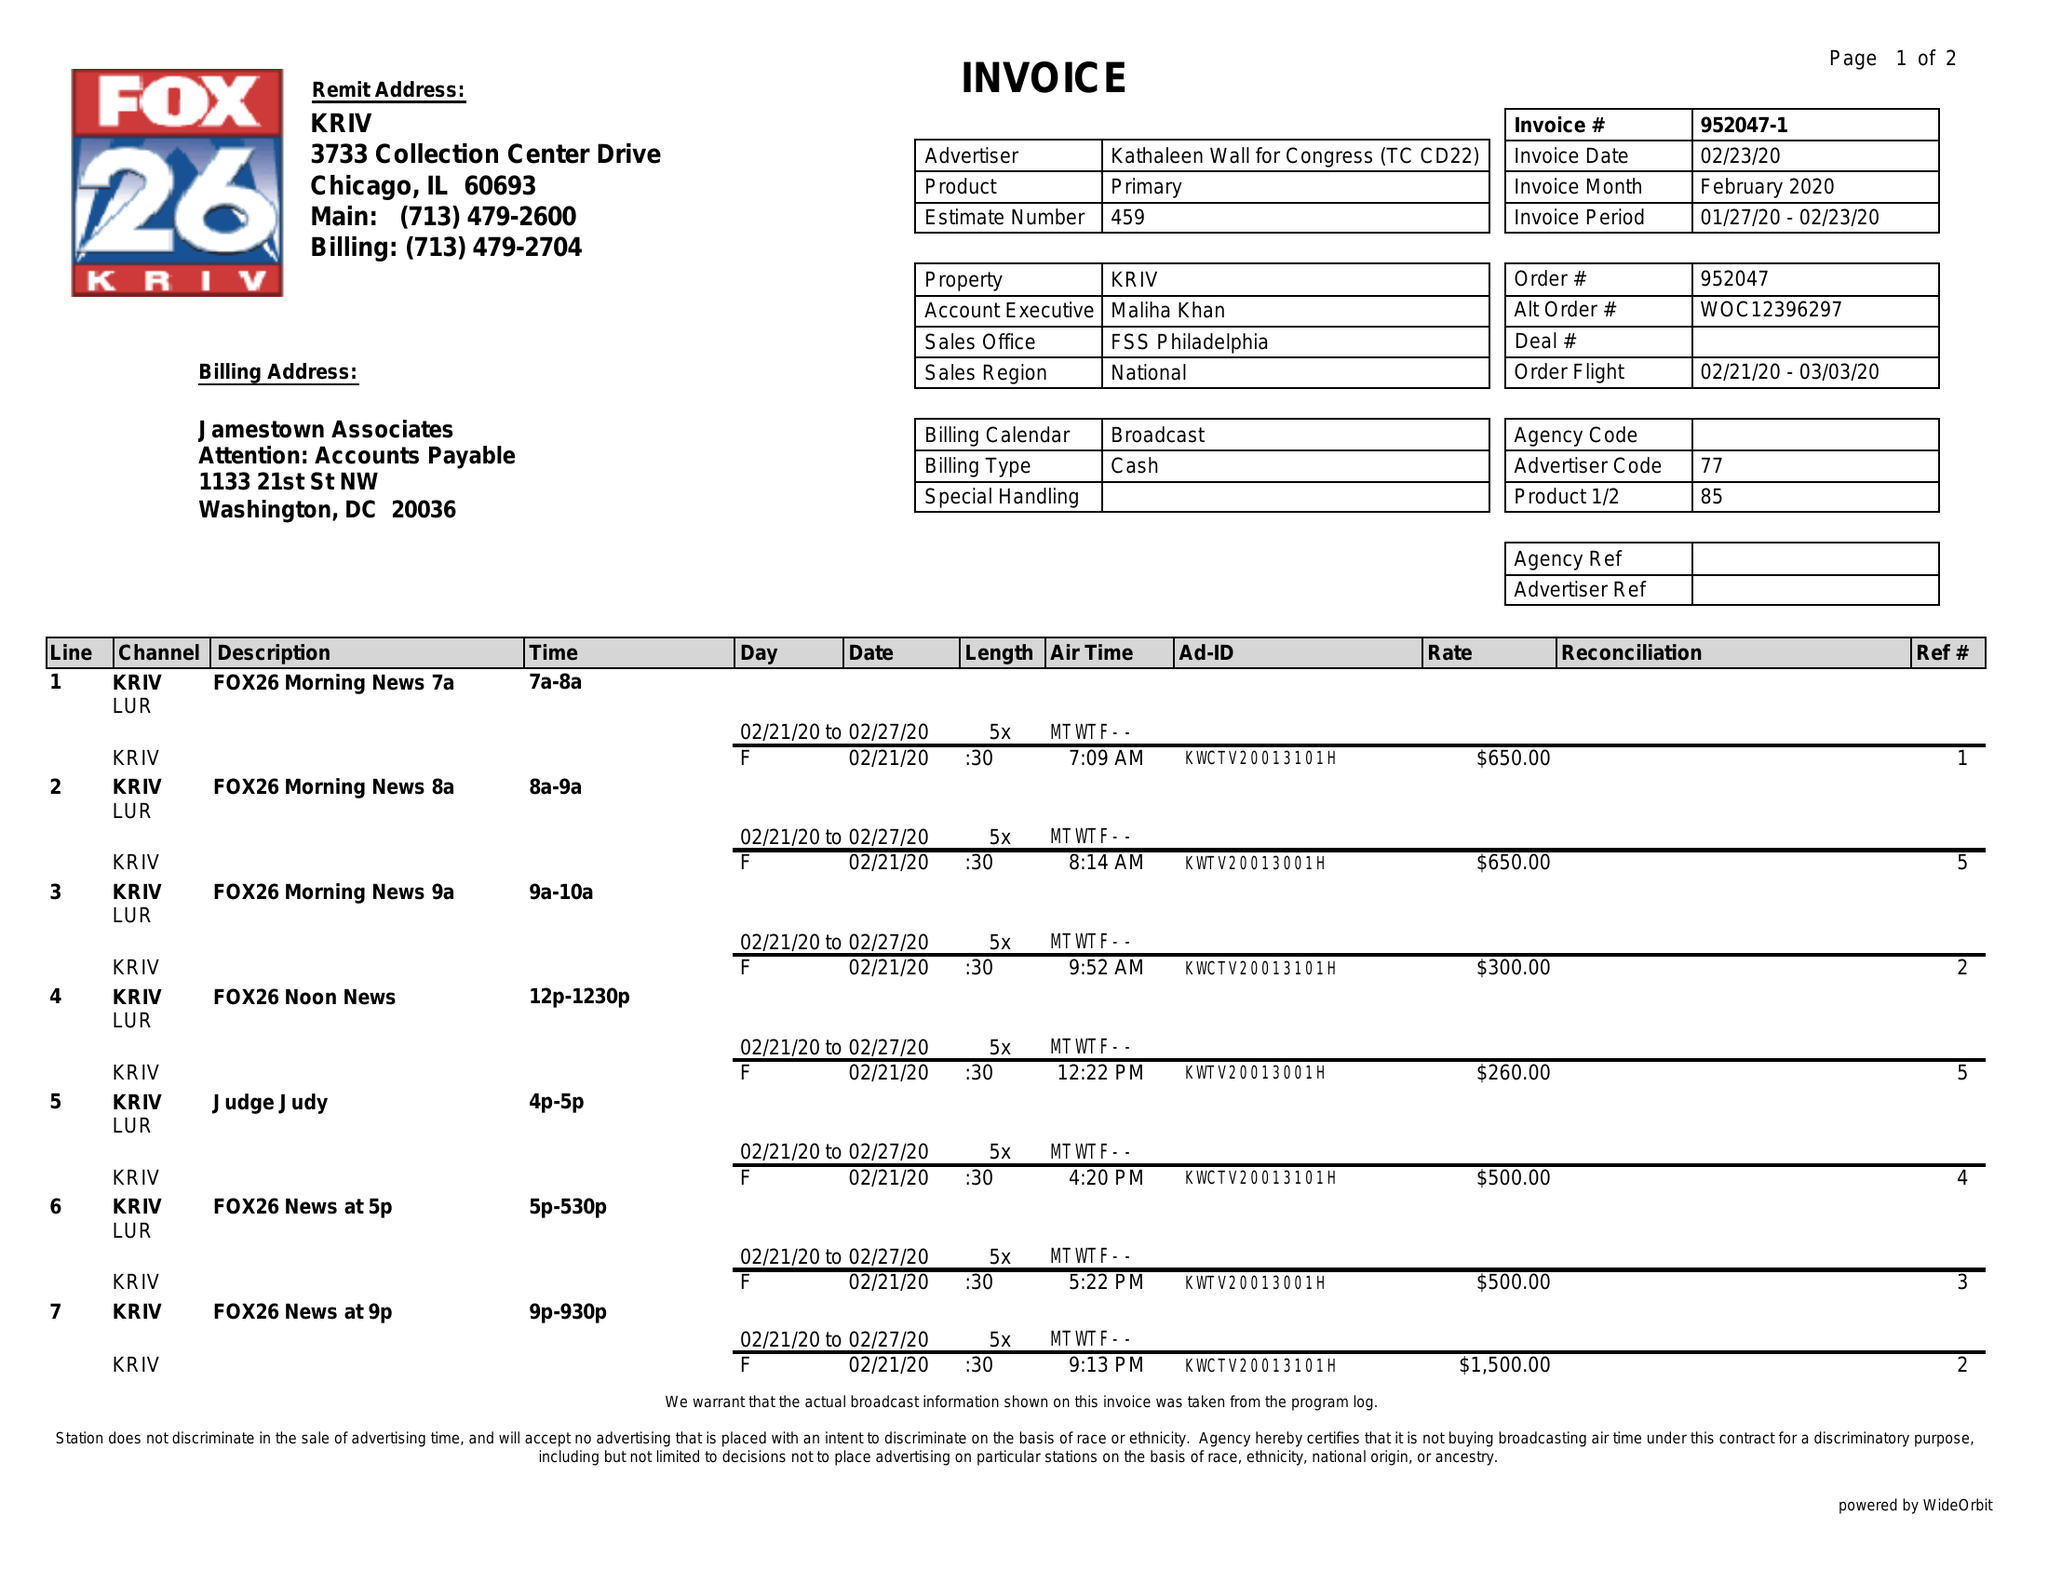What is the value for the gross_amount?
Answer the question using a single word or phrase. 5060.00 